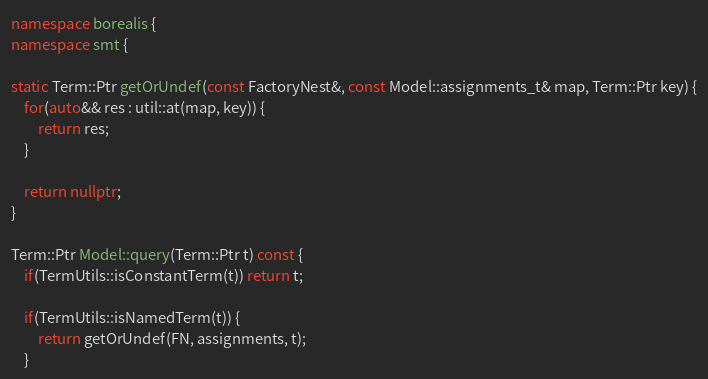Convert code to text. <code><loc_0><loc_0><loc_500><loc_500><_C++_>namespace borealis {
namespace smt {

static Term::Ptr getOrUndef(const FactoryNest&, const Model::assignments_t& map, Term::Ptr key) {
    for(auto&& res : util::at(map, key)) {
        return res;
    }

    return nullptr;
}

Term::Ptr Model::query(Term::Ptr t) const {
    if(TermUtils::isConstantTerm(t)) return t;

    if(TermUtils::isNamedTerm(t)) {
        return getOrUndef(FN, assignments, t);
    }
</code> 